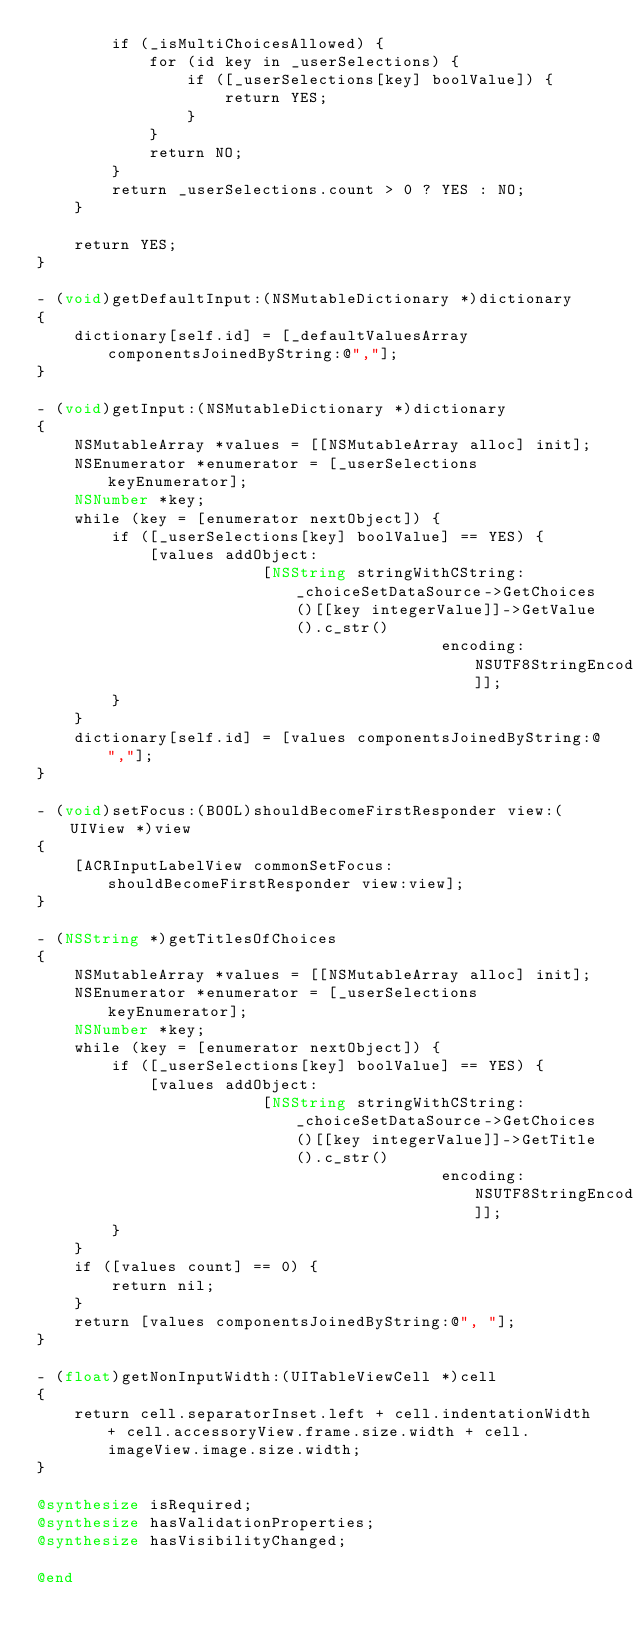Convert code to text. <code><loc_0><loc_0><loc_500><loc_500><_ObjectiveC_>        if (_isMultiChoicesAllowed) {
            for (id key in _userSelections) {
                if ([_userSelections[key] boolValue]) {
                    return YES;
                }
            }
            return NO;
        }
        return _userSelections.count > 0 ? YES : NO;
    }

    return YES;
}

- (void)getDefaultInput:(NSMutableDictionary *)dictionary
{
    dictionary[self.id] = [_defaultValuesArray componentsJoinedByString:@","];
}

- (void)getInput:(NSMutableDictionary *)dictionary
{
    NSMutableArray *values = [[NSMutableArray alloc] init];
    NSEnumerator *enumerator = [_userSelections keyEnumerator];
    NSNumber *key;
    while (key = [enumerator nextObject]) {
        if ([_userSelections[key] boolValue] == YES) {
            [values addObject:
                        [NSString stringWithCString:_choiceSetDataSource->GetChoices()[[key integerValue]]->GetValue().c_str()
                                           encoding:NSUTF8StringEncoding]];
        }
    }
    dictionary[self.id] = [values componentsJoinedByString:@","];
}

- (void)setFocus:(BOOL)shouldBecomeFirstResponder view:(UIView *)view
{
    [ACRInputLabelView commonSetFocus:shouldBecomeFirstResponder view:view];
}

- (NSString *)getTitlesOfChoices
{
    NSMutableArray *values = [[NSMutableArray alloc] init];
    NSEnumerator *enumerator = [_userSelections keyEnumerator];
    NSNumber *key;
    while (key = [enumerator nextObject]) {
        if ([_userSelections[key] boolValue] == YES) {
            [values addObject:
                        [NSString stringWithCString:_choiceSetDataSource->GetChoices()[[key integerValue]]->GetTitle().c_str()
                                           encoding:NSUTF8StringEncoding]];
        }
    }
    if ([values count] == 0) {
        return nil;
    }
    return [values componentsJoinedByString:@", "];
}

- (float)getNonInputWidth:(UITableViewCell *)cell
{
    return cell.separatorInset.left + cell.indentationWidth + cell.accessoryView.frame.size.width + cell.imageView.image.size.width;
}

@synthesize isRequired;
@synthesize hasValidationProperties;
@synthesize hasVisibilityChanged;

@end
</code> 